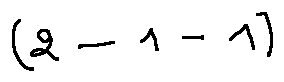Convert formula to latex. <formula><loc_0><loc_0><loc_500><loc_500>( 2 - 1 - 1 )</formula> 